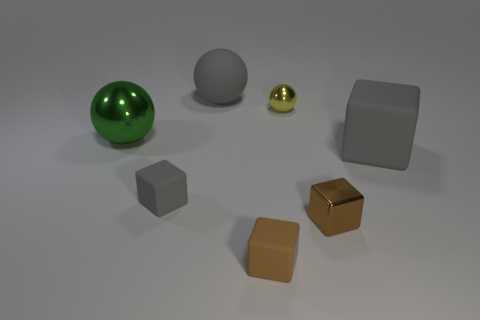Add 1 small purple cylinders. How many objects exist? 8 Subtract 3 cubes. How many cubes are left? 1 Add 2 big gray rubber objects. How many big gray rubber objects exist? 4 Subtract all gray balls. How many balls are left? 2 Subtract all tiny brown rubber cubes. How many cubes are left? 3 Subtract 1 yellow balls. How many objects are left? 6 Subtract all spheres. How many objects are left? 4 Subtract all blue balls. Subtract all gray blocks. How many balls are left? 3 Subtract all blue balls. How many brown blocks are left? 2 Subtract all small spheres. Subtract all green metal objects. How many objects are left? 5 